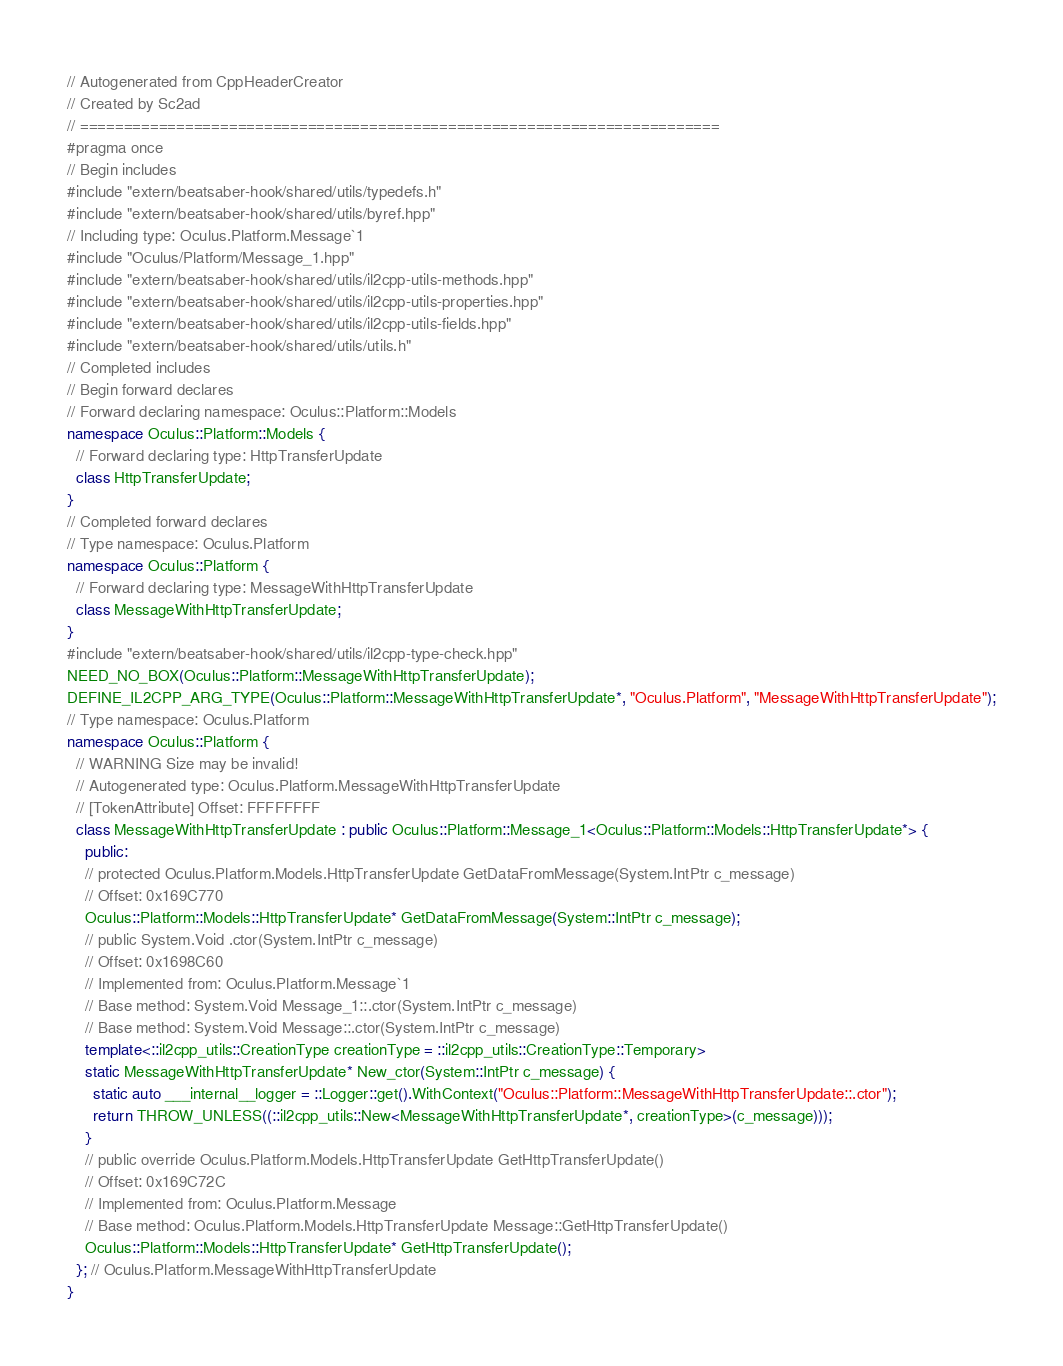Convert code to text. <code><loc_0><loc_0><loc_500><loc_500><_C++_>// Autogenerated from CppHeaderCreator
// Created by Sc2ad
// =========================================================================
#pragma once
// Begin includes
#include "extern/beatsaber-hook/shared/utils/typedefs.h"
#include "extern/beatsaber-hook/shared/utils/byref.hpp"
// Including type: Oculus.Platform.Message`1
#include "Oculus/Platform/Message_1.hpp"
#include "extern/beatsaber-hook/shared/utils/il2cpp-utils-methods.hpp"
#include "extern/beatsaber-hook/shared/utils/il2cpp-utils-properties.hpp"
#include "extern/beatsaber-hook/shared/utils/il2cpp-utils-fields.hpp"
#include "extern/beatsaber-hook/shared/utils/utils.h"
// Completed includes
// Begin forward declares
// Forward declaring namespace: Oculus::Platform::Models
namespace Oculus::Platform::Models {
  // Forward declaring type: HttpTransferUpdate
  class HttpTransferUpdate;
}
// Completed forward declares
// Type namespace: Oculus.Platform
namespace Oculus::Platform {
  // Forward declaring type: MessageWithHttpTransferUpdate
  class MessageWithHttpTransferUpdate;
}
#include "extern/beatsaber-hook/shared/utils/il2cpp-type-check.hpp"
NEED_NO_BOX(Oculus::Platform::MessageWithHttpTransferUpdate);
DEFINE_IL2CPP_ARG_TYPE(Oculus::Platform::MessageWithHttpTransferUpdate*, "Oculus.Platform", "MessageWithHttpTransferUpdate");
// Type namespace: Oculus.Platform
namespace Oculus::Platform {
  // WARNING Size may be invalid!
  // Autogenerated type: Oculus.Platform.MessageWithHttpTransferUpdate
  // [TokenAttribute] Offset: FFFFFFFF
  class MessageWithHttpTransferUpdate : public Oculus::Platform::Message_1<Oculus::Platform::Models::HttpTransferUpdate*> {
    public:
    // protected Oculus.Platform.Models.HttpTransferUpdate GetDataFromMessage(System.IntPtr c_message)
    // Offset: 0x169C770
    Oculus::Platform::Models::HttpTransferUpdate* GetDataFromMessage(System::IntPtr c_message);
    // public System.Void .ctor(System.IntPtr c_message)
    // Offset: 0x1698C60
    // Implemented from: Oculus.Platform.Message`1
    // Base method: System.Void Message_1::.ctor(System.IntPtr c_message)
    // Base method: System.Void Message::.ctor(System.IntPtr c_message)
    template<::il2cpp_utils::CreationType creationType = ::il2cpp_utils::CreationType::Temporary>
    static MessageWithHttpTransferUpdate* New_ctor(System::IntPtr c_message) {
      static auto ___internal__logger = ::Logger::get().WithContext("Oculus::Platform::MessageWithHttpTransferUpdate::.ctor");
      return THROW_UNLESS((::il2cpp_utils::New<MessageWithHttpTransferUpdate*, creationType>(c_message)));
    }
    // public override Oculus.Platform.Models.HttpTransferUpdate GetHttpTransferUpdate()
    // Offset: 0x169C72C
    // Implemented from: Oculus.Platform.Message
    // Base method: Oculus.Platform.Models.HttpTransferUpdate Message::GetHttpTransferUpdate()
    Oculus::Platform::Models::HttpTransferUpdate* GetHttpTransferUpdate();
  }; // Oculus.Platform.MessageWithHttpTransferUpdate
}</code> 